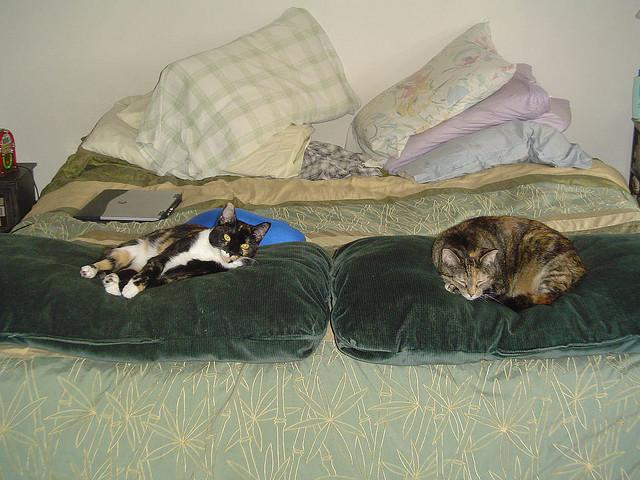How many cats are on pillows? two 